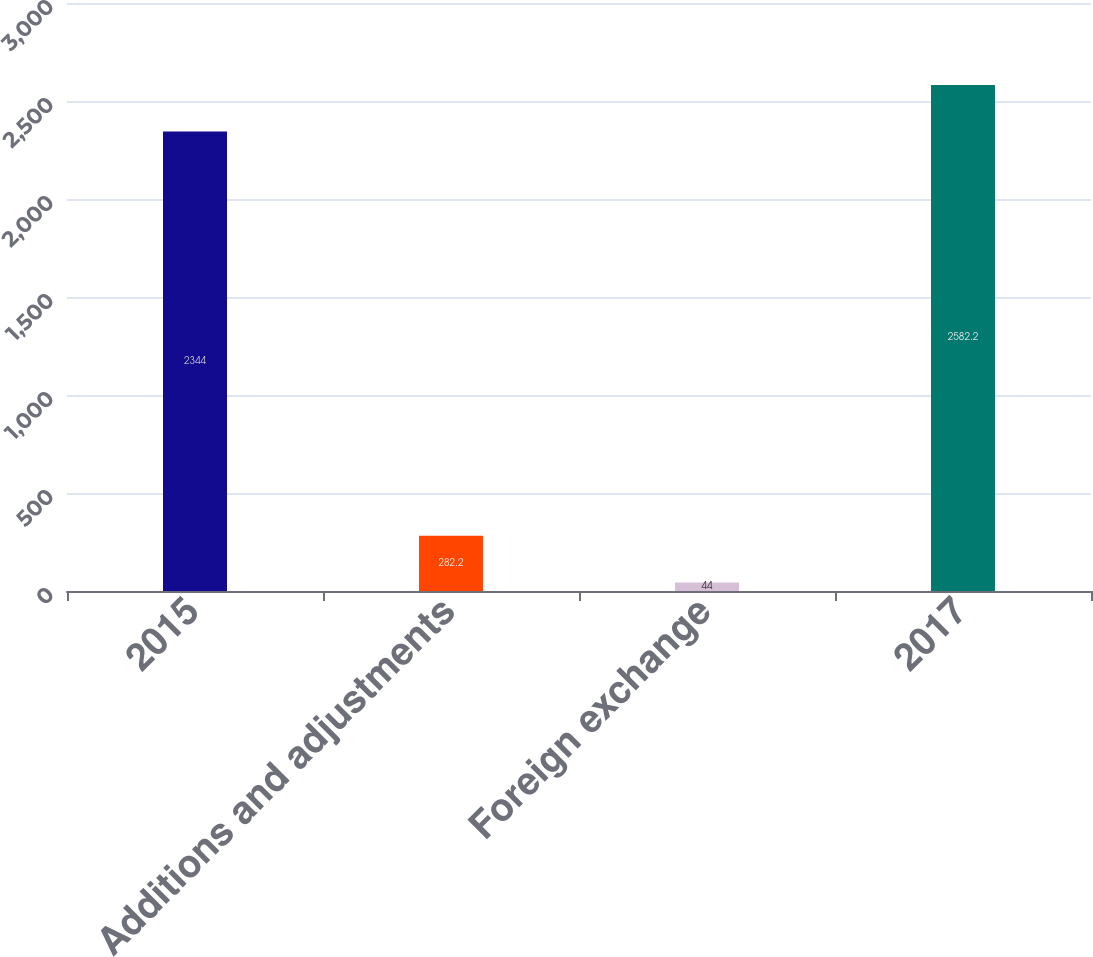<chart> <loc_0><loc_0><loc_500><loc_500><bar_chart><fcel>2015<fcel>Additions and adjustments<fcel>Foreign exchange<fcel>2017<nl><fcel>2344<fcel>282.2<fcel>44<fcel>2582.2<nl></chart> 